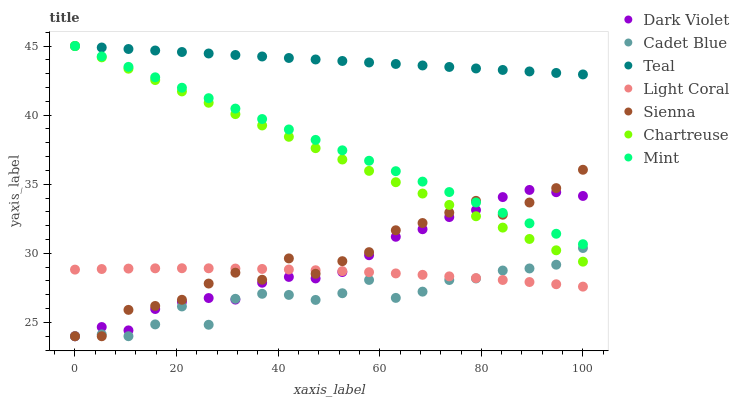Does Cadet Blue have the minimum area under the curve?
Answer yes or no. Yes. Does Teal have the maximum area under the curve?
Answer yes or no. Yes. Does Dark Violet have the minimum area under the curve?
Answer yes or no. No. Does Dark Violet have the maximum area under the curve?
Answer yes or no. No. Is Chartreuse the smoothest?
Answer yes or no. Yes. Is Sienna the roughest?
Answer yes or no. Yes. Is Cadet Blue the smoothest?
Answer yes or no. No. Is Cadet Blue the roughest?
Answer yes or no. No. Does Sienna have the lowest value?
Answer yes or no. Yes. Does Light Coral have the lowest value?
Answer yes or no. No. Does Mint have the highest value?
Answer yes or no. Yes. Does Cadet Blue have the highest value?
Answer yes or no. No. Is Cadet Blue less than Mint?
Answer yes or no. Yes. Is Teal greater than Dark Violet?
Answer yes or no. Yes. Does Chartreuse intersect Dark Violet?
Answer yes or no. Yes. Is Chartreuse less than Dark Violet?
Answer yes or no. No. Is Chartreuse greater than Dark Violet?
Answer yes or no. No. Does Cadet Blue intersect Mint?
Answer yes or no. No. 